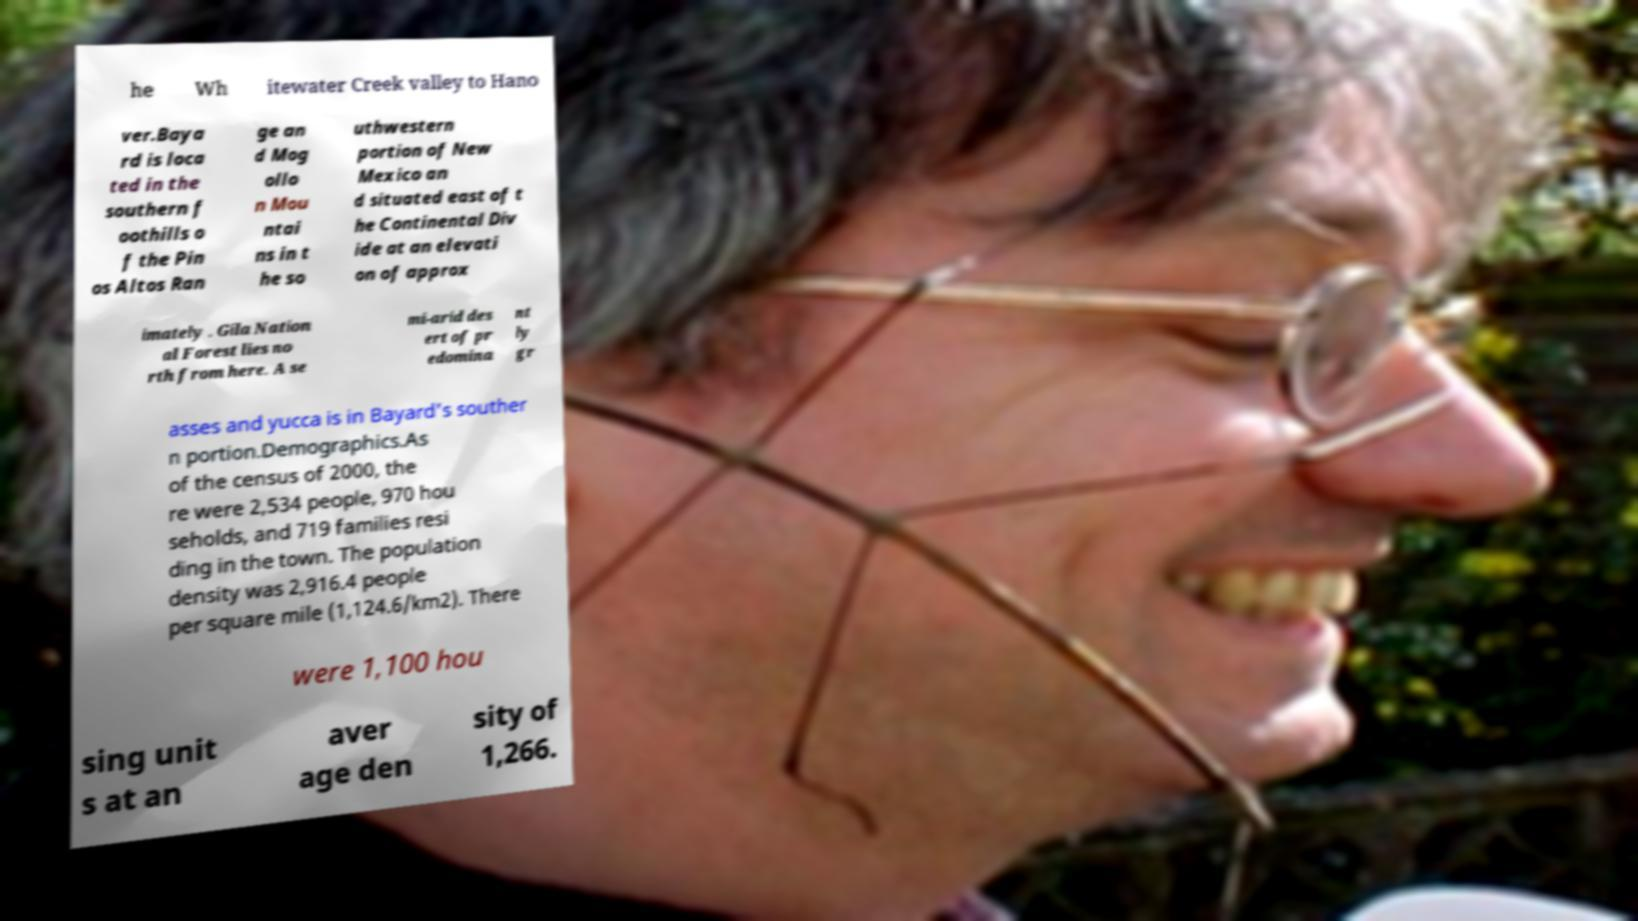Can you read and provide the text displayed in the image?This photo seems to have some interesting text. Can you extract and type it out for me? he Wh itewater Creek valley to Hano ver.Baya rd is loca ted in the southern f oothills o f the Pin os Altos Ran ge an d Mog ollo n Mou ntai ns in t he so uthwestern portion of New Mexico an d situated east of t he Continental Div ide at an elevati on of approx imately . Gila Nation al Forest lies no rth from here. A se mi-arid des ert of pr edomina nt ly gr asses and yucca is in Bayard's souther n portion.Demographics.As of the census of 2000, the re were 2,534 people, 970 hou seholds, and 719 families resi ding in the town. The population density was 2,916.4 people per square mile (1,124.6/km2). There were 1,100 hou sing unit s at an aver age den sity of 1,266. 